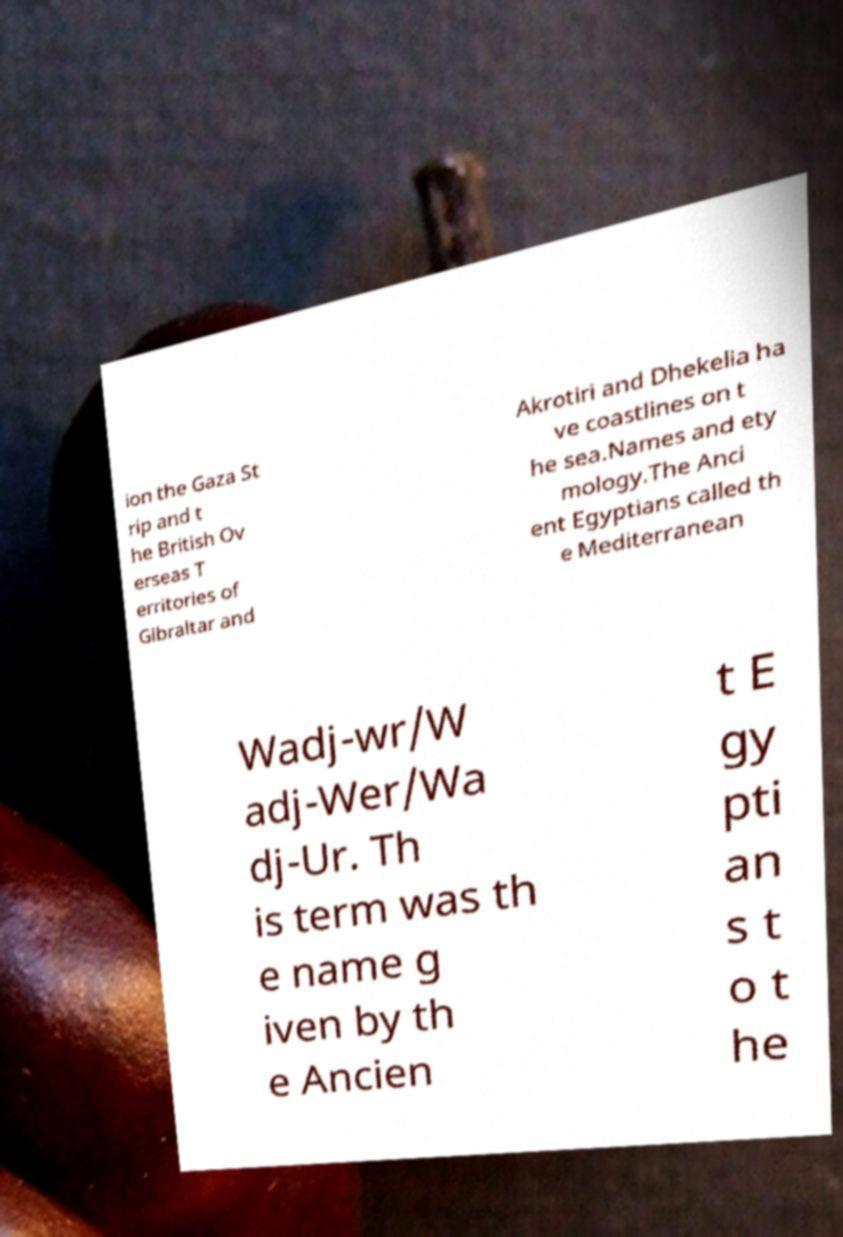For documentation purposes, I need the text within this image transcribed. Could you provide that? ion the Gaza St rip and t he British Ov erseas T erritories of Gibraltar and Akrotiri and Dhekelia ha ve coastlines on t he sea.Names and ety mology.The Anci ent Egyptians called th e Mediterranean Wadj-wr/W adj-Wer/Wa dj-Ur. Th is term was th e name g iven by th e Ancien t E gy pti an s t o t he 